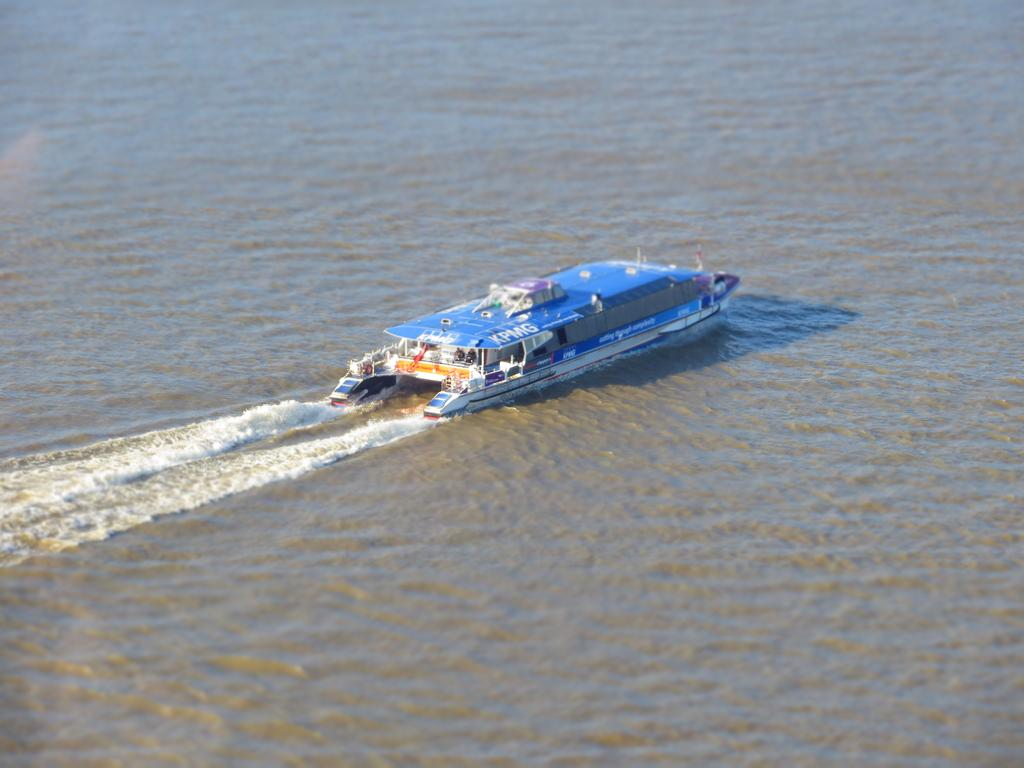What is the main subject of the image? The main subject of the image is a ship. Where is the ship located in the image? The ship is in the middle of a lake. What type of beef is being served at the airport near the lake in the image? There is no airport or beef present in the image; it features a ship in the middle of a lake. 